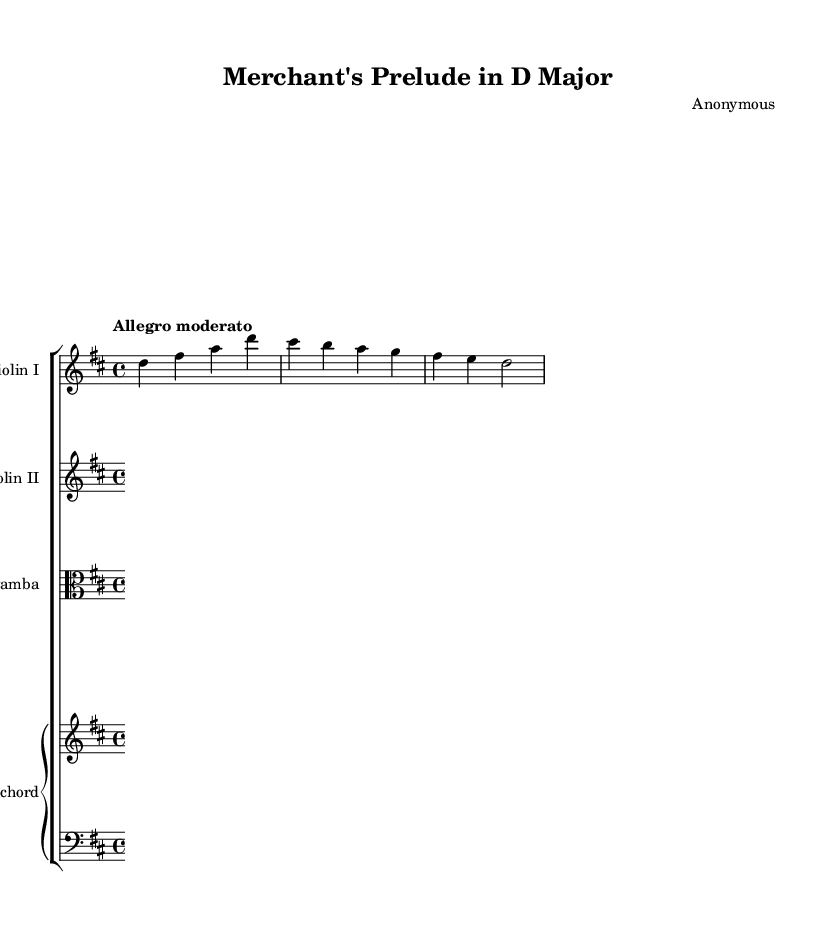What is the key signature of this music? The key signature shown in the music is D major, which contains two sharps (F# and C#). This can be identified at the beginning of the score where the key signature is placed.
Answer: D major What is the time signature of this piece? The time signature is 4/4, indicated at the start of the score, which means there are four beats in a measure and the quarter note receives one beat.
Answer: 4/4 What is the tempo marking for this piece? The tempo marking is "Allegro moderato," indicating a moderately fast tempo. This can be seen immediately following the time signature.
Answer: Allegro moderato How many staves are present in this score? There are four staves present in the score: two violins, one viola, and one combined staff for the harpsichord. By counting the distinct sections within the score layout, we can confirm this.
Answer: Four What instrumentation is used in this chamber music? The instrumentation includes two violins, a viola da gamba, and a harpsichord. This can be deduced from the labeled staves in the score indicating the specific instruments.
Answer: Violin I, Violin II, Viola da gamba, Harpsichord What is the primary role of the harpsichord in this piece? The harpsichord's primary role is to provide a walking bass line, supporting the harmonic structure and rhythm of the ensemble, which is indicated in its part within the score.
Answer: Walking bass line What style of music does this piece represent? This piece represents Baroque chamber music, characterized by its use of ornamentation, counterpoint, and the structure typical of the Baroque period, reflected in the specific instruments and composition style.
Answer: Baroque chamber music 